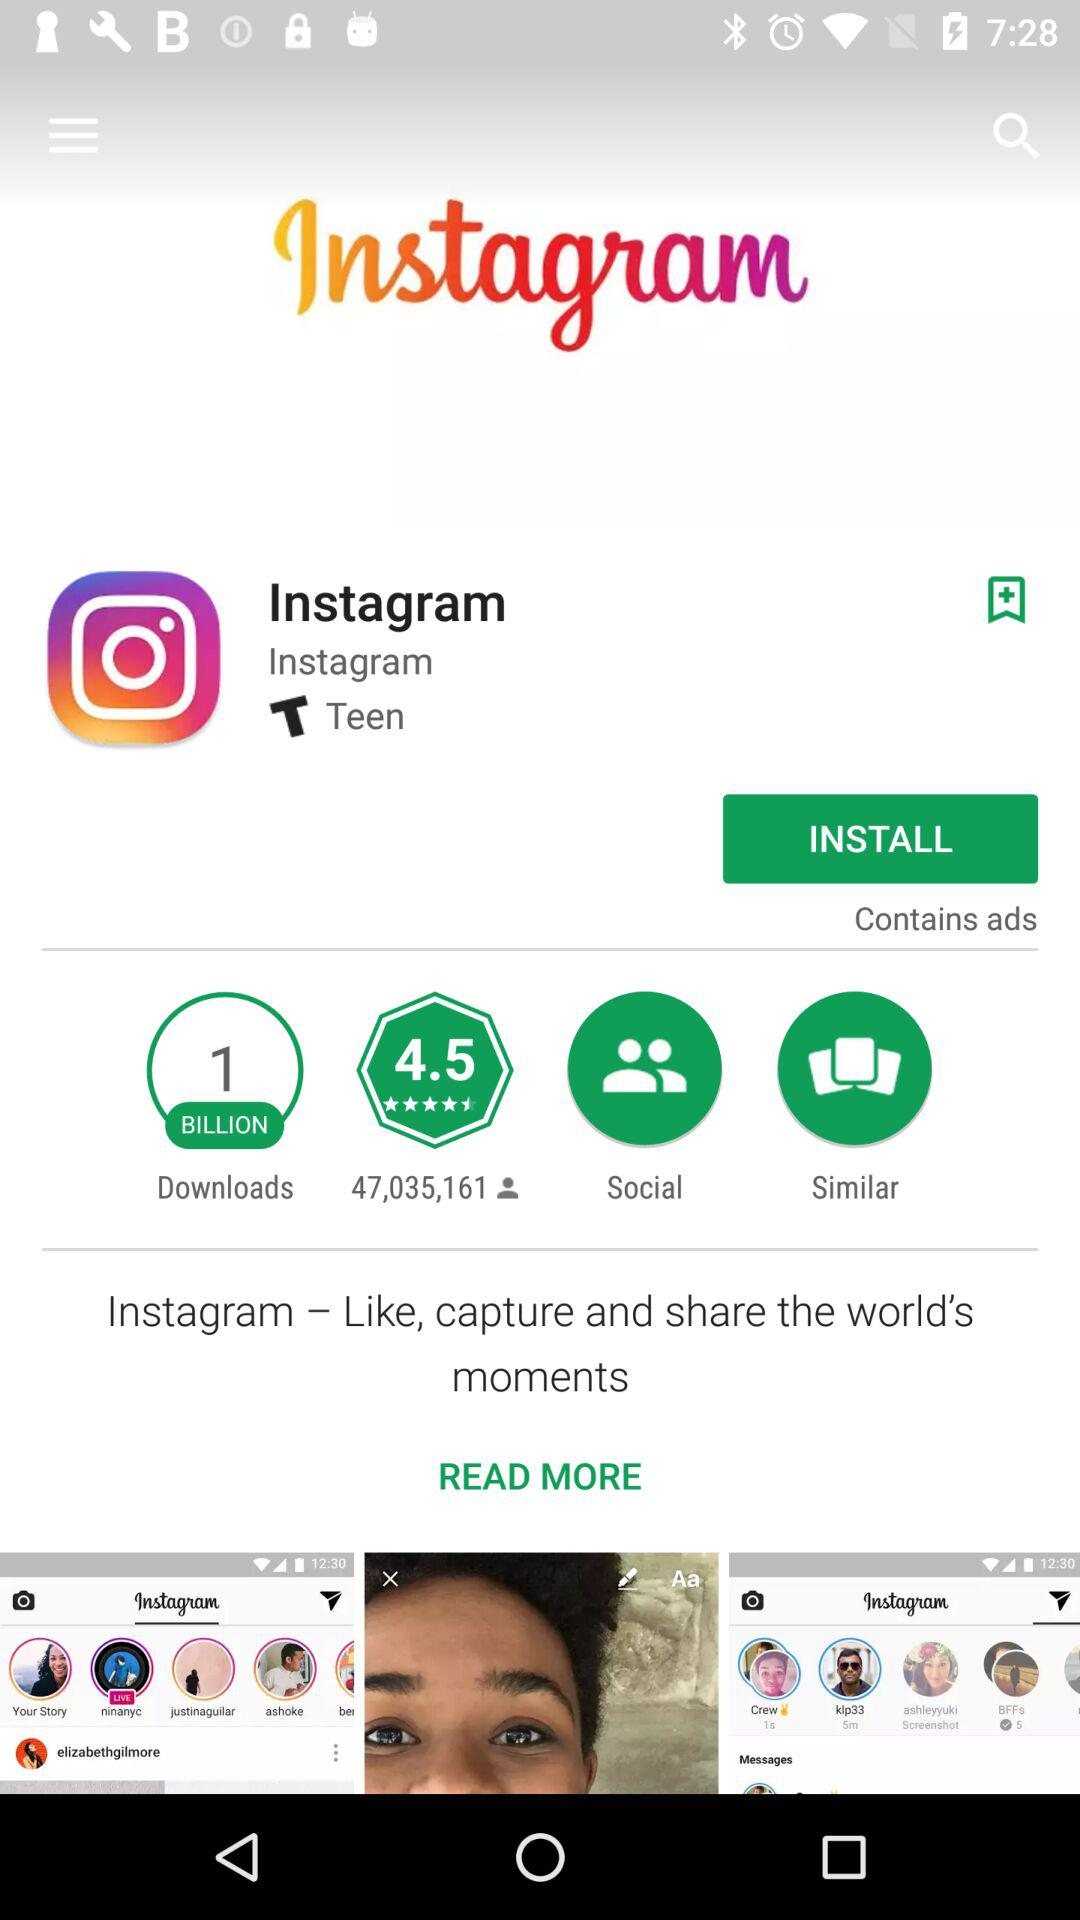What is the application name? The application name is "Instagram". 